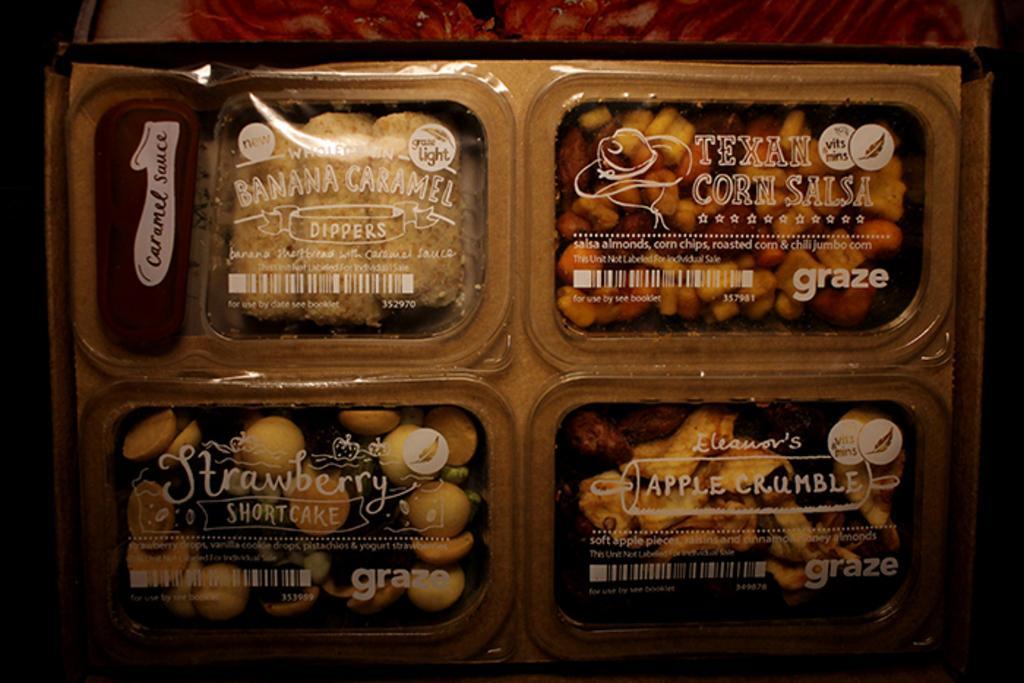Could you give a brief overview of what you see in this image? In this image, we can see some food items packed in a box. We can also see some text on the top of the box. We can also see some object at the top. 